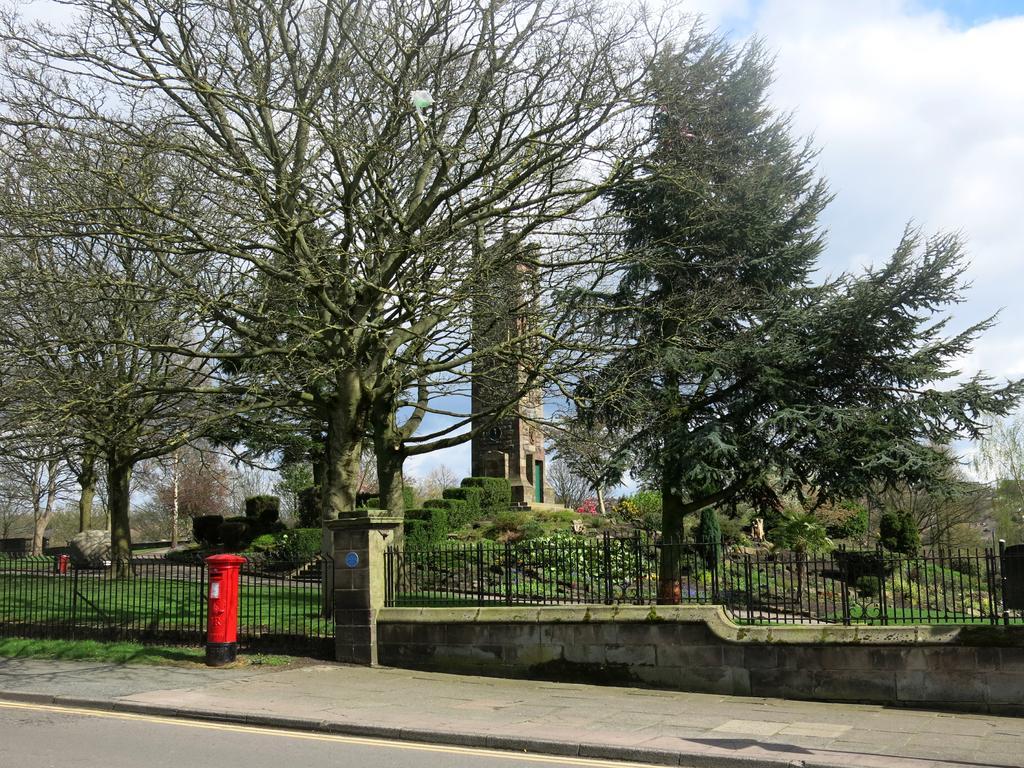Can you describe this image briefly? In this picture we can see a post box on the ground, beside this ground we can see a fence, trees, tower, plants and some objects and in the background we can see sky with clouds. 